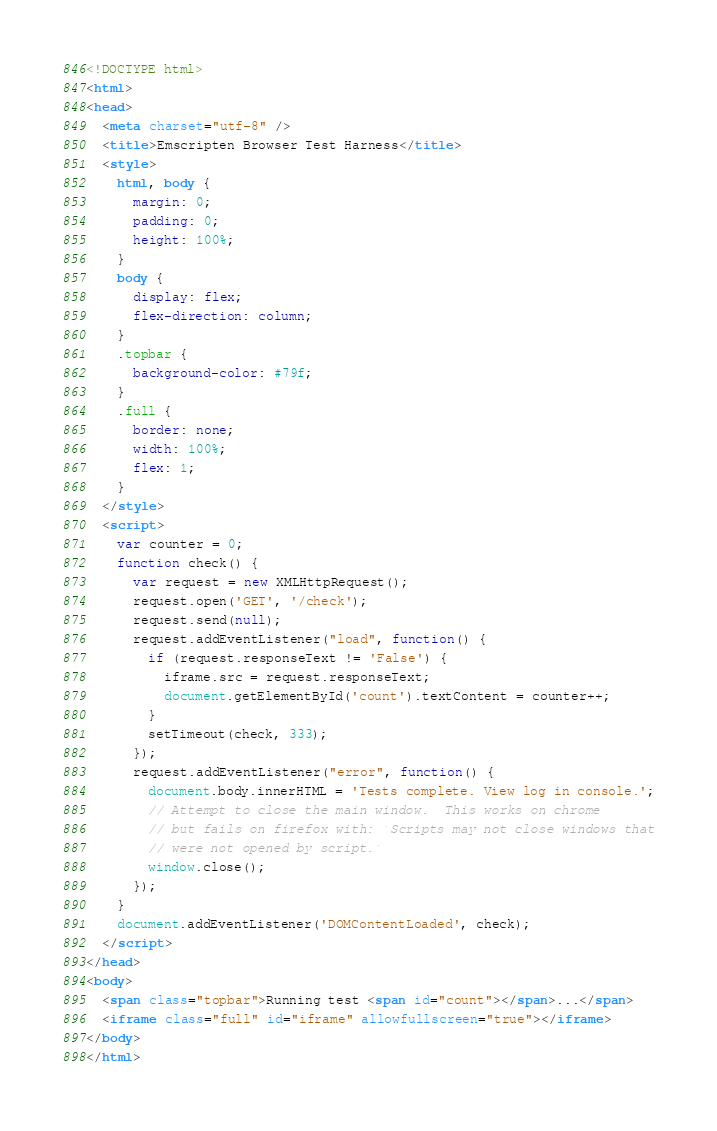<code> <loc_0><loc_0><loc_500><loc_500><_HTML_><!DOCTYPE html>
<html>
<head>
  <meta charset="utf-8" />
  <title>Emscripten Browser Test Harness</title>
  <style>
    html, body {
      margin: 0;
      padding: 0;
      height: 100%;
    }
    body {
      display: flex;
      flex-direction: column;
    }
    .topbar {
      background-color: #79f;
    }
    .full {
      border: none;
      width: 100%;
      flex: 1;
    }
  </style>
  <script>
    var counter = 0;
    function check() {
      var request = new XMLHttpRequest();
      request.open('GET', '/check');
      request.send(null);
      request.addEventListener("load", function() {
        if (request.responseText != 'False') {
          iframe.src = request.responseText;
          document.getElementById('count').textContent = counter++;
        }
        setTimeout(check, 333);
      });
      request.addEventListener("error", function() {
        document.body.innerHTML = 'Tests complete. View log in console.';
        // Attempt to close the main window.  This works on chrome
        // but fails on firefox with: `Scripts may not close windows that
        // were not opened by script.`
        window.close();
      });
    }
    document.addEventListener('DOMContentLoaded', check);
  </script>
</head>
<body>
  <span class="topbar">Running test <span id="count"></span>...</span>
  <iframe class="full" id="iframe" allowfullscreen="true"></iframe>
</body>
</html>

</code> 